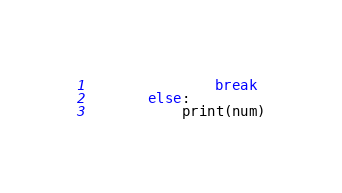<code> <loc_0><loc_0><loc_500><loc_500><_Python_>               break
       else:
           print(num)
</code> 